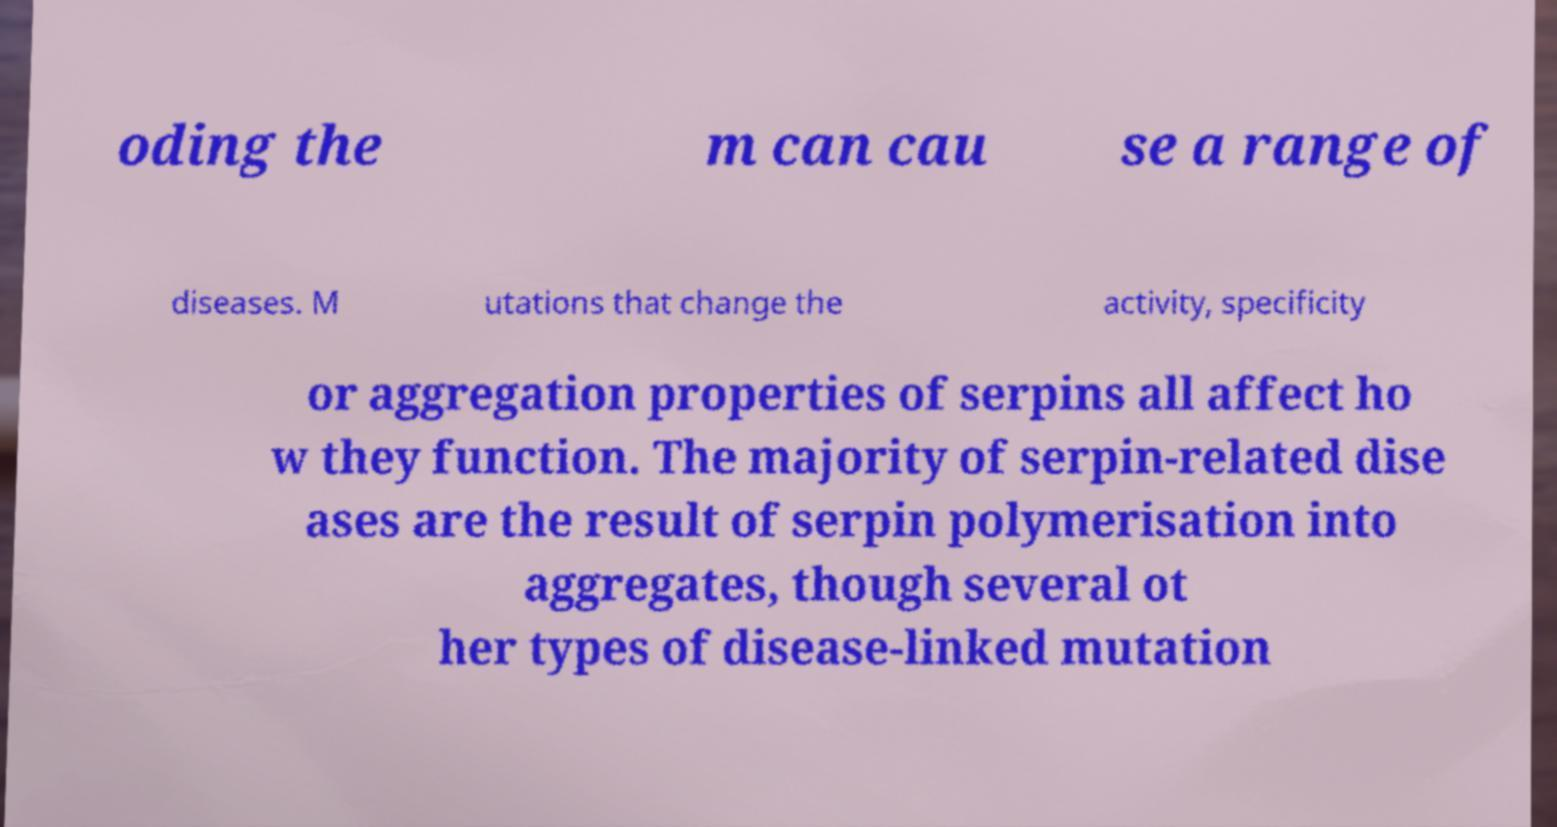What messages or text are displayed in this image? I need them in a readable, typed format. oding the m can cau se a range of diseases. M utations that change the activity, specificity or aggregation properties of serpins all affect ho w they function. The majority of serpin-related dise ases are the result of serpin polymerisation into aggregates, though several ot her types of disease-linked mutation 